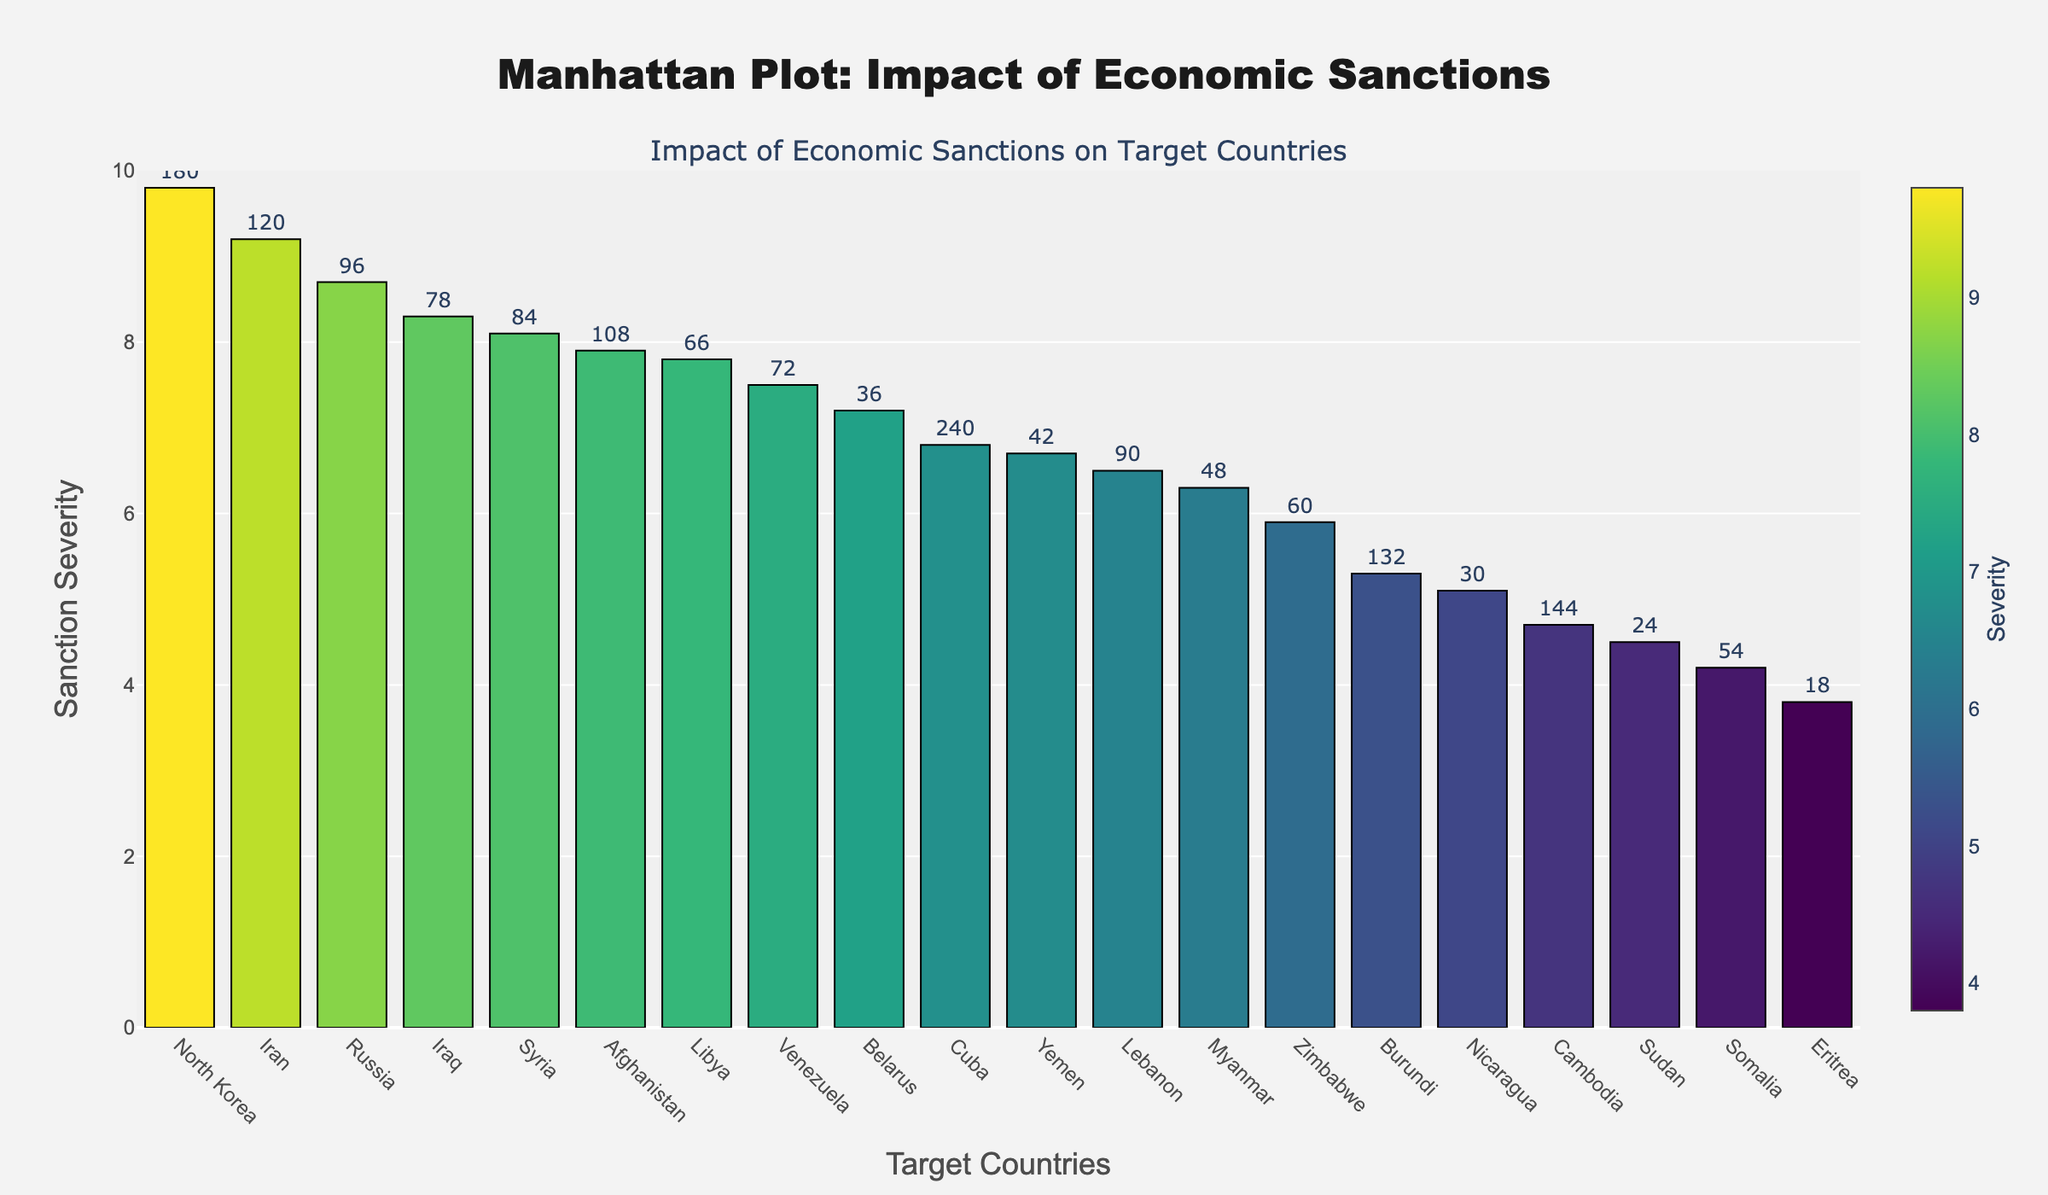What's the title of the plot? Look at the top center of the figure where the title is usually located. It shows the overall subject of the plot.
Answer: Manhattan Plot: Impact of Economic Sanctions What is the y-axis labeled? Check the left side of the plot where the label for the y-axis would be located. It describes what the vertical position of each bar represents.
Answer: Sanction Severity Which country has the highest sanction severity? Look for the bar that reaches the highest value on the y-axis. The label at the base of this bar will give the country name.
Answer: North Korea Which country has the lowest sanction severity? Look for the bar that reaches the lowest value on the y-axis. The label at the base of this bar indicates the country's name.
Answer: Eritrea What is the duration of the sanctions on Venezuela? Hover over the bar corresponding to Venezuela or find it visually, then note the duration given in the hover template or text above.
Answer: 72 months Which sector in Russia is affected by economic sanctions, and what is its severity? Identify the bar corresponding to Russia. The text above or hover template will indicate the sector, and the bar height indicates the severity.
Answer: Energy, 8.7 How many countries have a sanction severity greater than 8? Count the number of bars that extend above the 8 on the y-axis.
Answer: 7 What is the range of the y-axis for sanction severity? Look at the numerical labels along the y-axis to determine the minimum and maximum values.
Answer: 0 to 10 Which sector has a sanction severity of exactly 5.9, and which country does it affect? Find the bar that aligns with the y-axis at 5.9; the label at the base and hover template will give the sector and country.
Answer: Mining, Zimbabwe Compare the sanction severity of Iran and Iraq. Which country has a higher value, and by how much? Find the bars for Iran and Iraq; subtract the sanction severity value of Iraq from Iran to get the difference.
Answer: Iran has a higher sanction severity by 0.9 